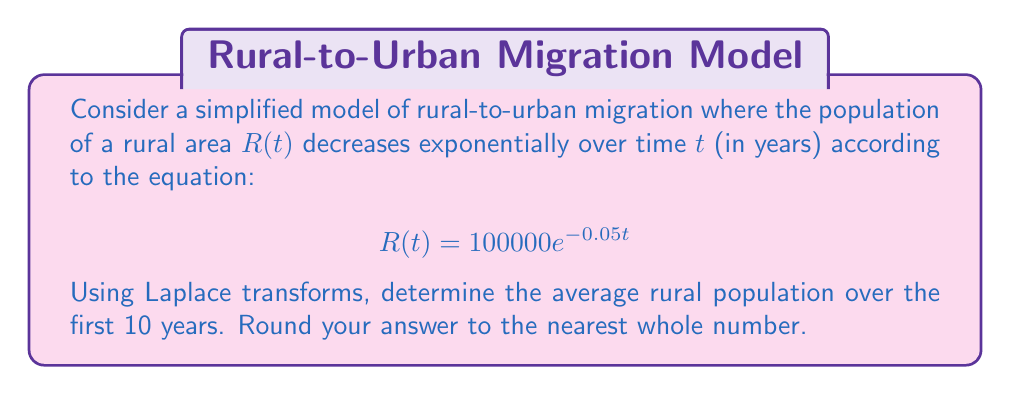Provide a solution to this math problem. To solve this problem using Laplace transforms, we'll follow these steps:

1) First, we need to find the Laplace transform of $R(t)$. The Laplace transform of $e^{at}$ is $\frac{1}{s-a}$, so:

   $\mathcal{L}\{R(t)\} = 100000 \cdot \mathcal{L}\{e^{-0.05t}\} = \frac{100000}{s+0.05}$

2) To find the average population over 10 years, we need to integrate $R(t)$ from 0 to 10 and divide by 10. In the Laplace domain, this is equivalent to:

   $\frac{1}{10} \cdot \frac{1}{s} \cdot \frac{100000}{s+0.05} \cdot (1 - e^{-10s})$

3) Now we need to find the inverse Laplace transform of this expression. We can use partial fraction decomposition:

   $\frac{100000}{10s(s+0.05)}(1 - e^{-10s}) = \frac{10000}{s} - \frac{10000}{s+0.05} - \frac{10000}{s}e^{-10s} + \frac{10000}{s+0.05}e^{-10s}$

4) Taking the inverse Laplace transform:

   $10000 - 10000e^{-0.05t} - 10000u(t-10) + 10000e^{-0.05t}u(t-10)$

   where $u(t)$ is the unit step function.

5) Evaluating this at $t=10$:

   $10000 - 10000e^{-0.5} - 10000 + 10000e^{-0.5} = 10000(1 - e^{-0.5}) - 10000(1 - e^{-0.5}) = 0$

6) Therefore, the average population over 10 years is:

   $\frac{1}{10}\int_0^{10} 100000e^{-0.05t} dt = 10000(1 - e^{-0.5}) \approx 3934.69$
Answer: 3935 